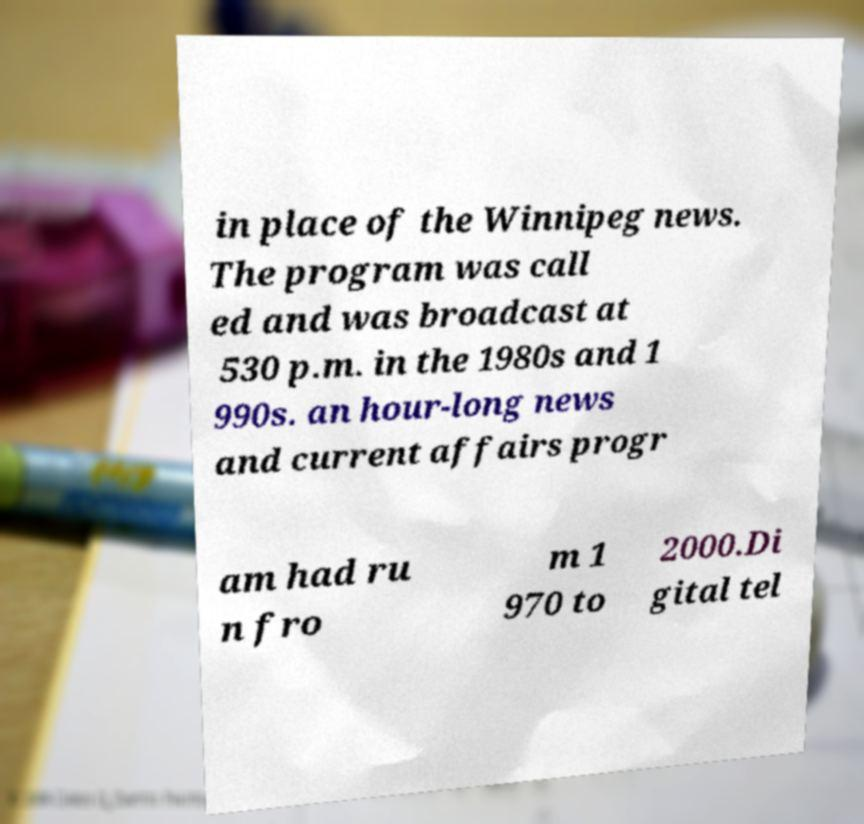Please identify and transcribe the text found in this image. in place of the Winnipeg news. The program was call ed and was broadcast at 530 p.m. in the 1980s and 1 990s. an hour-long news and current affairs progr am had ru n fro m 1 970 to 2000.Di gital tel 